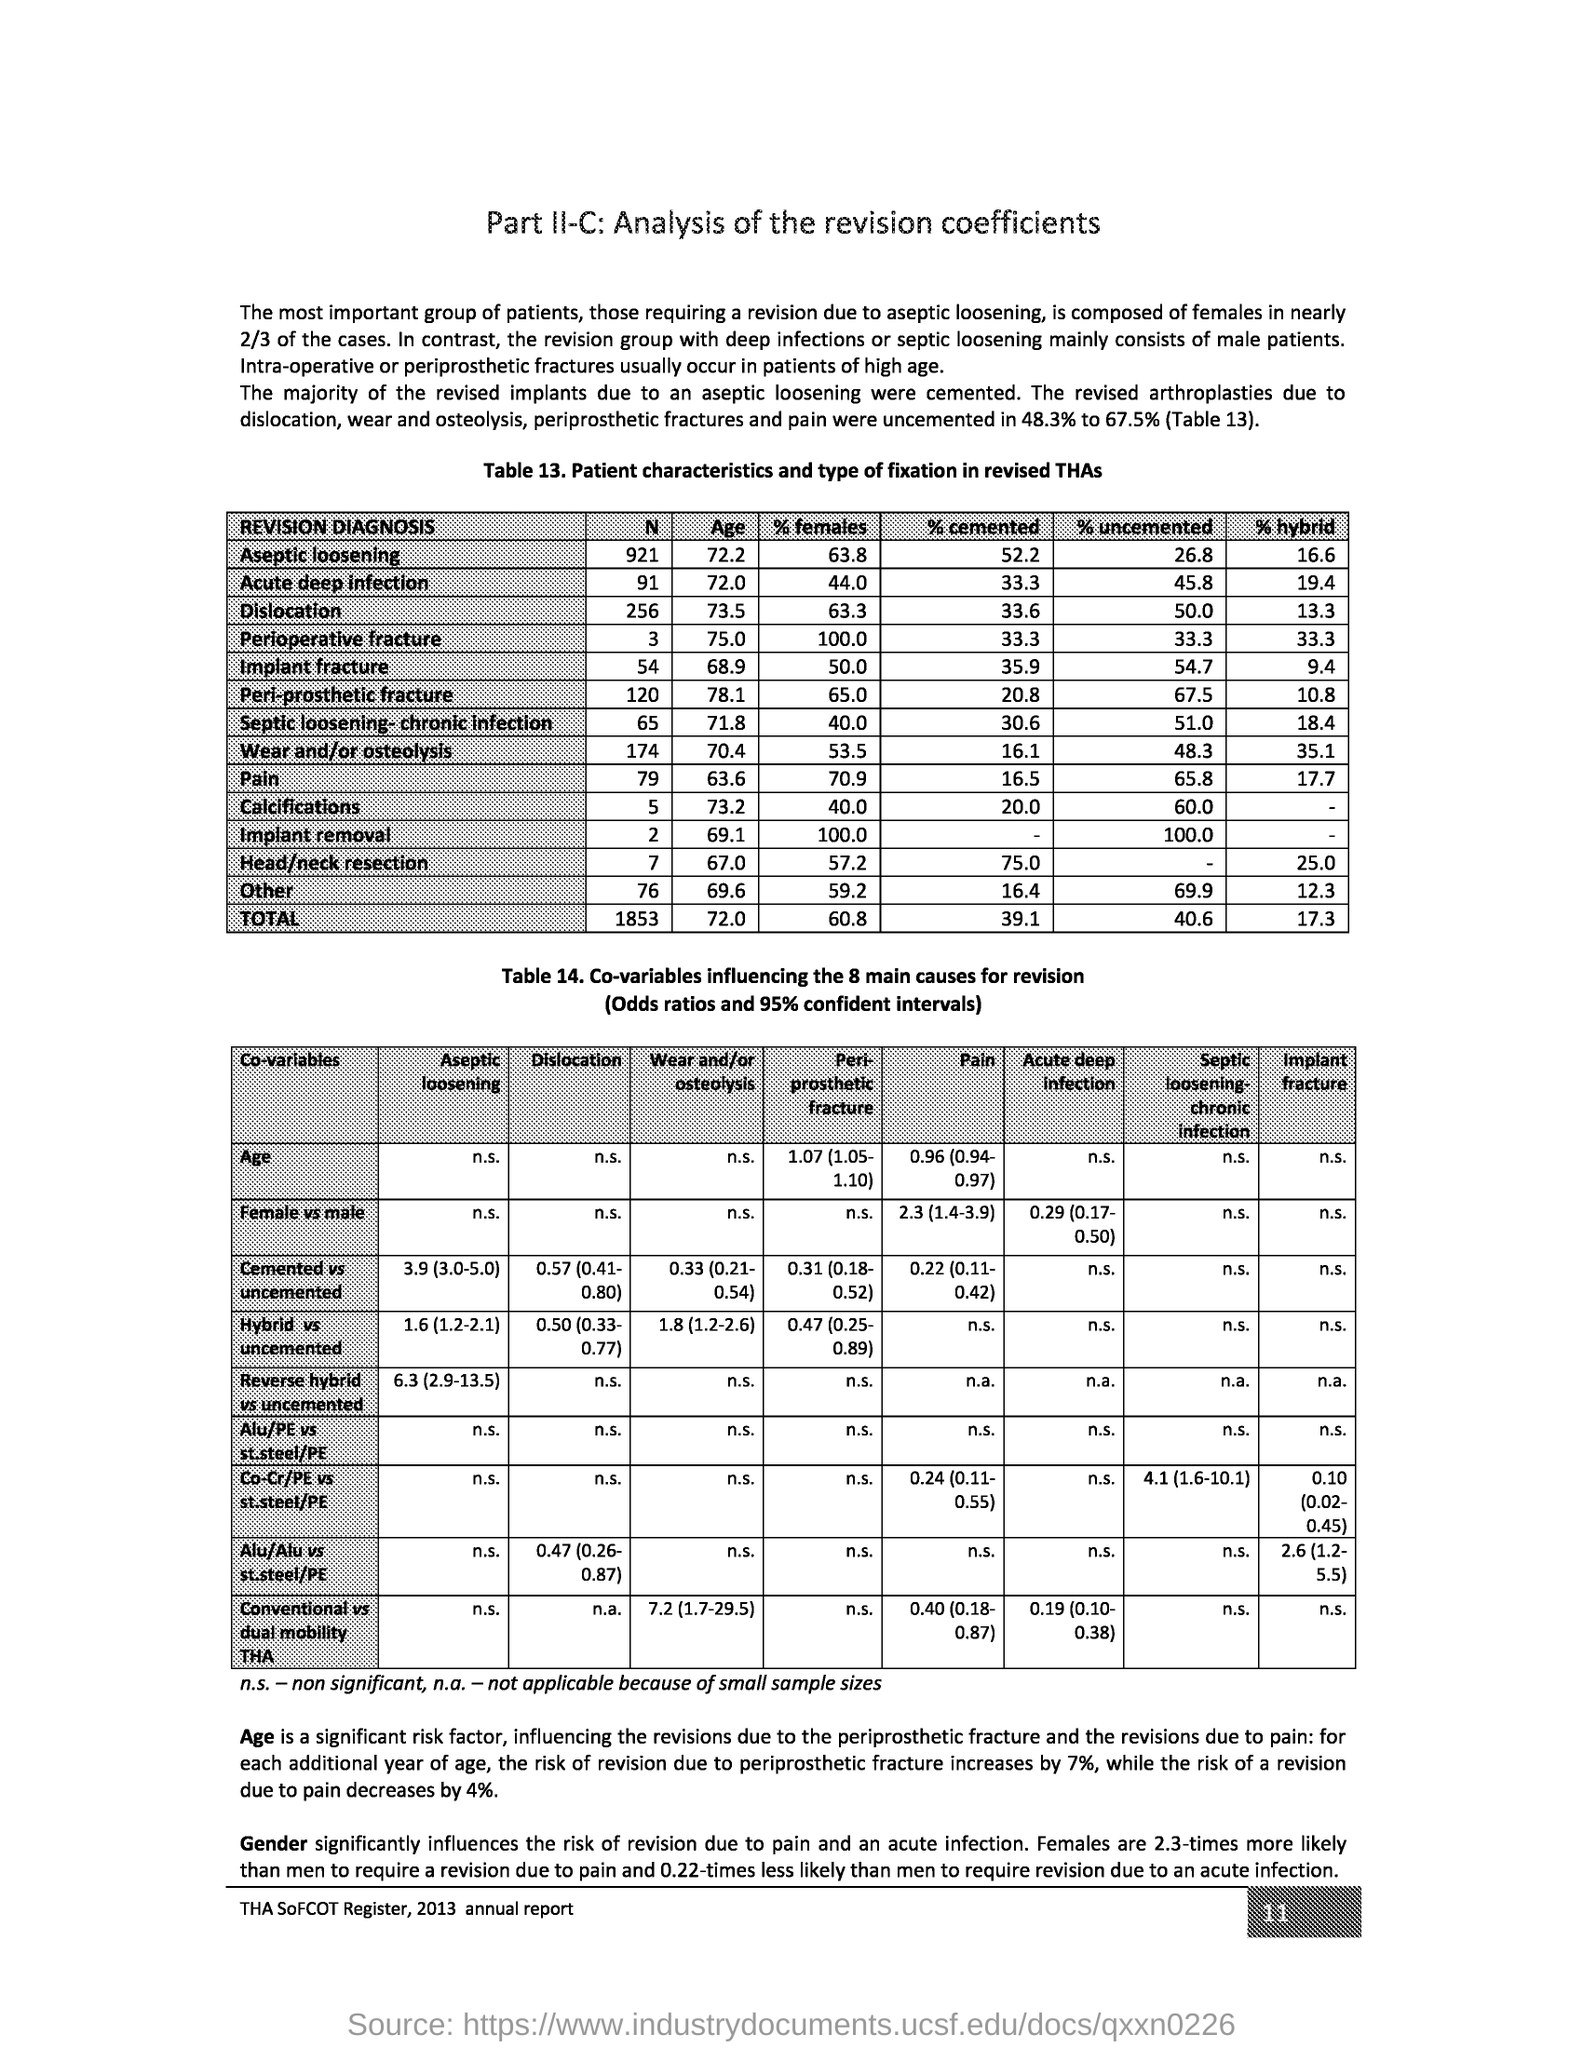What is the Page Number?
Make the answer very short. 11. 